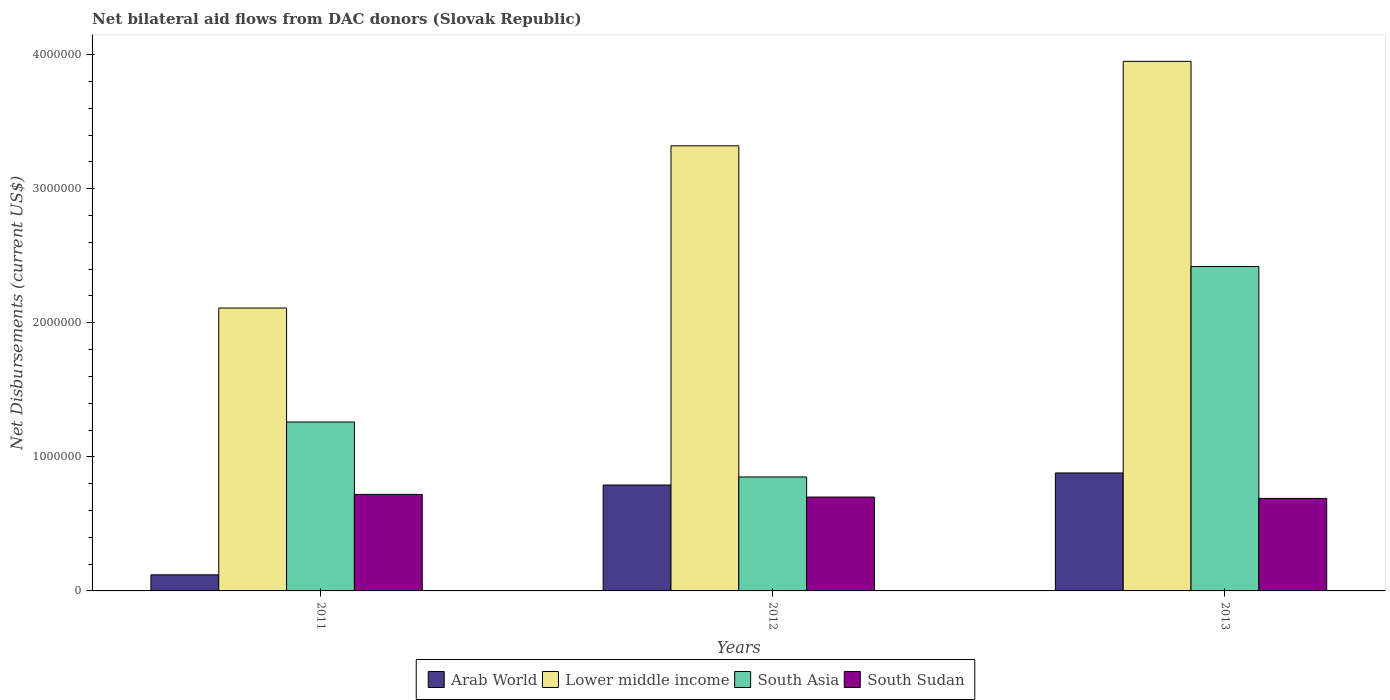Are the number of bars per tick equal to the number of legend labels?
Give a very brief answer. Yes. What is the net bilateral aid flows in South Asia in 2011?
Give a very brief answer. 1.26e+06. Across all years, what is the maximum net bilateral aid flows in South Asia?
Offer a terse response. 2.42e+06. Across all years, what is the minimum net bilateral aid flows in South Sudan?
Your answer should be compact. 6.90e+05. What is the total net bilateral aid flows in South Asia in the graph?
Your response must be concise. 4.53e+06. What is the difference between the net bilateral aid flows in South Asia in 2011 and that in 2013?
Your answer should be very brief. -1.16e+06. What is the difference between the net bilateral aid flows in South Asia in 2012 and the net bilateral aid flows in Lower middle income in 2013?
Offer a very short reply. -3.10e+06. What is the average net bilateral aid flows in Arab World per year?
Offer a very short reply. 5.97e+05. In the year 2012, what is the difference between the net bilateral aid flows in Arab World and net bilateral aid flows in South Asia?
Give a very brief answer. -6.00e+04. What is the ratio of the net bilateral aid flows in South Asia in 2011 to that in 2012?
Your answer should be very brief. 1.48. Is the net bilateral aid flows in South Sudan in 2011 less than that in 2012?
Your answer should be compact. No. What is the difference between the highest and the second highest net bilateral aid flows in South Asia?
Keep it short and to the point. 1.16e+06. What is the difference between the highest and the lowest net bilateral aid flows in Lower middle income?
Keep it short and to the point. 1.84e+06. In how many years, is the net bilateral aid flows in South Sudan greater than the average net bilateral aid flows in South Sudan taken over all years?
Make the answer very short. 1. Is the sum of the net bilateral aid flows in Lower middle income in 2011 and 2012 greater than the maximum net bilateral aid flows in South Sudan across all years?
Your response must be concise. Yes. What does the 1st bar from the left in 2012 represents?
Provide a succinct answer. Arab World. What does the 2nd bar from the right in 2013 represents?
Give a very brief answer. South Asia. How many bars are there?
Make the answer very short. 12. How many years are there in the graph?
Your response must be concise. 3. What is the difference between two consecutive major ticks on the Y-axis?
Keep it short and to the point. 1.00e+06. Does the graph contain any zero values?
Give a very brief answer. No. Where does the legend appear in the graph?
Your answer should be very brief. Bottom center. How many legend labels are there?
Provide a short and direct response. 4. How are the legend labels stacked?
Your response must be concise. Horizontal. What is the title of the graph?
Give a very brief answer. Net bilateral aid flows from DAC donors (Slovak Republic). Does "Latvia" appear as one of the legend labels in the graph?
Ensure brevity in your answer.  No. What is the label or title of the X-axis?
Make the answer very short. Years. What is the label or title of the Y-axis?
Provide a succinct answer. Net Disbursements (current US$). What is the Net Disbursements (current US$) of Arab World in 2011?
Make the answer very short. 1.20e+05. What is the Net Disbursements (current US$) of Lower middle income in 2011?
Offer a very short reply. 2.11e+06. What is the Net Disbursements (current US$) in South Asia in 2011?
Make the answer very short. 1.26e+06. What is the Net Disbursements (current US$) of South Sudan in 2011?
Give a very brief answer. 7.20e+05. What is the Net Disbursements (current US$) of Arab World in 2012?
Provide a short and direct response. 7.90e+05. What is the Net Disbursements (current US$) in Lower middle income in 2012?
Make the answer very short. 3.32e+06. What is the Net Disbursements (current US$) in South Asia in 2012?
Give a very brief answer. 8.50e+05. What is the Net Disbursements (current US$) of Arab World in 2013?
Your answer should be compact. 8.80e+05. What is the Net Disbursements (current US$) in Lower middle income in 2013?
Provide a succinct answer. 3.95e+06. What is the Net Disbursements (current US$) of South Asia in 2013?
Your answer should be very brief. 2.42e+06. What is the Net Disbursements (current US$) in South Sudan in 2013?
Your answer should be compact. 6.90e+05. Across all years, what is the maximum Net Disbursements (current US$) in Arab World?
Give a very brief answer. 8.80e+05. Across all years, what is the maximum Net Disbursements (current US$) in Lower middle income?
Give a very brief answer. 3.95e+06. Across all years, what is the maximum Net Disbursements (current US$) of South Asia?
Give a very brief answer. 2.42e+06. Across all years, what is the maximum Net Disbursements (current US$) of South Sudan?
Provide a succinct answer. 7.20e+05. Across all years, what is the minimum Net Disbursements (current US$) of Lower middle income?
Your answer should be very brief. 2.11e+06. Across all years, what is the minimum Net Disbursements (current US$) of South Asia?
Make the answer very short. 8.50e+05. Across all years, what is the minimum Net Disbursements (current US$) in South Sudan?
Your answer should be very brief. 6.90e+05. What is the total Net Disbursements (current US$) of Arab World in the graph?
Offer a very short reply. 1.79e+06. What is the total Net Disbursements (current US$) of Lower middle income in the graph?
Keep it short and to the point. 9.38e+06. What is the total Net Disbursements (current US$) of South Asia in the graph?
Your response must be concise. 4.53e+06. What is the total Net Disbursements (current US$) of South Sudan in the graph?
Provide a short and direct response. 2.11e+06. What is the difference between the Net Disbursements (current US$) of Arab World in 2011 and that in 2012?
Your answer should be very brief. -6.70e+05. What is the difference between the Net Disbursements (current US$) of Lower middle income in 2011 and that in 2012?
Your answer should be very brief. -1.21e+06. What is the difference between the Net Disbursements (current US$) in Arab World in 2011 and that in 2013?
Offer a very short reply. -7.60e+05. What is the difference between the Net Disbursements (current US$) of Lower middle income in 2011 and that in 2013?
Offer a very short reply. -1.84e+06. What is the difference between the Net Disbursements (current US$) of South Asia in 2011 and that in 2013?
Give a very brief answer. -1.16e+06. What is the difference between the Net Disbursements (current US$) in South Sudan in 2011 and that in 2013?
Offer a terse response. 3.00e+04. What is the difference between the Net Disbursements (current US$) in Lower middle income in 2012 and that in 2013?
Your response must be concise. -6.30e+05. What is the difference between the Net Disbursements (current US$) of South Asia in 2012 and that in 2013?
Give a very brief answer. -1.57e+06. What is the difference between the Net Disbursements (current US$) in Arab World in 2011 and the Net Disbursements (current US$) in Lower middle income in 2012?
Provide a succinct answer. -3.20e+06. What is the difference between the Net Disbursements (current US$) in Arab World in 2011 and the Net Disbursements (current US$) in South Asia in 2012?
Ensure brevity in your answer.  -7.30e+05. What is the difference between the Net Disbursements (current US$) of Arab World in 2011 and the Net Disbursements (current US$) of South Sudan in 2012?
Your answer should be very brief. -5.80e+05. What is the difference between the Net Disbursements (current US$) in Lower middle income in 2011 and the Net Disbursements (current US$) in South Asia in 2012?
Keep it short and to the point. 1.26e+06. What is the difference between the Net Disbursements (current US$) of Lower middle income in 2011 and the Net Disbursements (current US$) of South Sudan in 2012?
Give a very brief answer. 1.41e+06. What is the difference between the Net Disbursements (current US$) of South Asia in 2011 and the Net Disbursements (current US$) of South Sudan in 2012?
Provide a succinct answer. 5.60e+05. What is the difference between the Net Disbursements (current US$) in Arab World in 2011 and the Net Disbursements (current US$) in Lower middle income in 2013?
Provide a short and direct response. -3.83e+06. What is the difference between the Net Disbursements (current US$) of Arab World in 2011 and the Net Disbursements (current US$) of South Asia in 2013?
Your response must be concise. -2.30e+06. What is the difference between the Net Disbursements (current US$) of Arab World in 2011 and the Net Disbursements (current US$) of South Sudan in 2013?
Make the answer very short. -5.70e+05. What is the difference between the Net Disbursements (current US$) in Lower middle income in 2011 and the Net Disbursements (current US$) in South Asia in 2013?
Give a very brief answer. -3.10e+05. What is the difference between the Net Disbursements (current US$) of Lower middle income in 2011 and the Net Disbursements (current US$) of South Sudan in 2013?
Offer a terse response. 1.42e+06. What is the difference between the Net Disbursements (current US$) in South Asia in 2011 and the Net Disbursements (current US$) in South Sudan in 2013?
Keep it short and to the point. 5.70e+05. What is the difference between the Net Disbursements (current US$) of Arab World in 2012 and the Net Disbursements (current US$) of Lower middle income in 2013?
Provide a succinct answer. -3.16e+06. What is the difference between the Net Disbursements (current US$) of Arab World in 2012 and the Net Disbursements (current US$) of South Asia in 2013?
Provide a succinct answer. -1.63e+06. What is the difference between the Net Disbursements (current US$) in Arab World in 2012 and the Net Disbursements (current US$) in South Sudan in 2013?
Ensure brevity in your answer.  1.00e+05. What is the difference between the Net Disbursements (current US$) of Lower middle income in 2012 and the Net Disbursements (current US$) of South Sudan in 2013?
Your answer should be compact. 2.63e+06. What is the difference between the Net Disbursements (current US$) of South Asia in 2012 and the Net Disbursements (current US$) of South Sudan in 2013?
Offer a very short reply. 1.60e+05. What is the average Net Disbursements (current US$) in Arab World per year?
Your answer should be compact. 5.97e+05. What is the average Net Disbursements (current US$) in Lower middle income per year?
Offer a terse response. 3.13e+06. What is the average Net Disbursements (current US$) of South Asia per year?
Your answer should be very brief. 1.51e+06. What is the average Net Disbursements (current US$) of South Sudan per year?
Make the answer very short. 7.03e+05. In the year 2011, what is the difference between the Net Disbursements (current US$) of Arab World and Net Disbursements (current US$) of Lower middle income?
Offer a terse response. -1.99e+06. In the year 2011, what is the difference between the Net Disbursements (current US$) of Arab World and Net Disbursements (current US$) of South Asia?
Offer a very short reply. -1.14e+06. In the year 2011, what is the difference between the Net Disbursements (current US$) in Arab World and Net Disbursements (current US$) in South Sudan?
Provide a short and direct response. -6.00e+05. In the year 2011, what is the difference between the Net Disbursements (current US$) of Lower middle income and Net Disbursements (current US$) of South Asia?
Make the answer very short. 8.50e+05. In the year 2011, what is the difference between the Net Disbursements (current US$) in Lower middle income and Net Disbursements (current US$) in South Sudan?
Offer a very short reply. 1.39e+06. In the year 2011, what is the difference between the Net Disbursements (current US$) of South Asia and Net Disbursements (current US$) of South Sudan?
Your response must be concise. 5.40e+05. In the year 2012, what is the difference between the Net Disbursements (current US$) of Arab World and Net Disbursements (current US$) of Lower middle income?
Keep it short and to the point. -2.53e+06. In the year 2012, what is the difference between the Net Disbursements (current US$) in Arab World and Net Disbursements (current US$) in South Asia?
Your answer should be compact. -6.00e+04. In the year 2012, what is the difference between the Net Disbursements (current US$) in Lower middle income and Net Disbursements (current US$) in South Asia?
Make the answer very short. 2.47e+06. In the year 2012, what is the difference between the Net Disbursements (current US$) of Lower middle income and Net Disbursements (current US$) of South Sudan?
Your response must be concise. 2.62e+06. In the year 2013, what is the difference between the Net Disbursements (current US$) in Arab World and Net Disbursements (current US$) in Lower middle income?
Keep it short and to the point. -3.07e+06. In the year 2013, what is the difference between the Net Disbursements (current US$) of Arab World and Net Disbursements (current US$) of South Asia?
Your answer should be compact. -1.54e+06. In the year 2013, what is the difference between the Net Disbursements (current US$) in Arab World and Net Disbursements (current US$) in South Sudan?
Ensure brevity in your answer.  1.90e+05. In the year 2013, what is the difference between the Net Disbursements (current US$) in Lower middle income and Net Disbursements (current US$) in South Asia?
Your answer should be compact. 1.53e+06. In the year 2013, what is the difference between the Net Disbursements (current US$) of Lower middle income and Net Disbursements (current US$) of South Sudan?
Make the answer very short. 3.26e+06. In the year 2013, what is the difference between the Net Disbursements (current US$) in South Asia and Net Disbursements (current US$) in South Sudan?
Provide a succinct answer. 1.73e+06. What is the ratio of the Net Disbursements (current US$) of Arab World in 2011 to that in 2012?
Your answer should be compact. 0.15. What is the ratio of the Net Disbursements (current US$) in Lower middle income in 2011 to that in 2012?
Provide a short and direct response. 0.64. What is the ratio of the Net Disbursements (current US$) of South Asia in 2011 to that in 2012?
Give a very brief answer. 1.48. What is the ratio of the Net Disbursements (current US$) of South Sudan in 2011 to that in 2012?
Make the answer very short. 1.03. What is the ratio of the Net Disbursements (current US$) in Arab World in 2011 to that in 2013?
Offer a terse response. 0.14. What is the ratio of the Net Disbursements (current US$) of Lower middle income in 2011 to that in 2013?
Make the answer very short. 0.53. What is the ratio of the Net Disbursements (current US$) in South Asia in 2011 to that in 2013?
Your answer should be very brief. 0.52. What is the ratio of the Net Disbursements (current US$) of South Sudan in 2011 to that in 2013?
Offer a terse response. 1.04. What is the ratio of the Net Disbursements (current US$) of Arab World in 2012 to that in 2013?
Offer a very short reply. 0.9. What is the ratio of the Net Disbursements (current US$) in Lower middle income in 2012 to that in 2013?
Ensure brevity in your answer.  0.84. What is the ratio of the Net Disbursements (current US$) of South Asia in 2012 to that in 2013?
Your answer should be very brief. 0.35. What is the ratio of the Net Disbursements (current US$) in South Sudan in 2012 to that in 2013?
Ensure brevity in your answer.  1.01. What is the difference between the highest and the second highest Net Disbursements (current US$) of Lower middle income?
Ensure brevity in your answer.  6.30e+05. What is the difference between the highest and the second highest Net Disbursements (current US$) of South Asia?
Your answer should be compact. 1.16e+06. What is the difference between the highest and the lowest Net Disbursements (current US$) of Arab World?
Ensure brevity in your answer.  7.60e+05. What is the difference between the highest and the lowest Net Disbursements (current US$) in Lower middle income?
Make the answer very short. 1.84e+06. What is the difference between the highest and the lowest Net Disbursements (current US$) of South Asia?
Ensure brevity in your answer.  1.57e+06. What is the difference between the highest and the lowest Net Disbursements (current US$) in South Sudan?
Offer a terse response. 3.00e+04. 